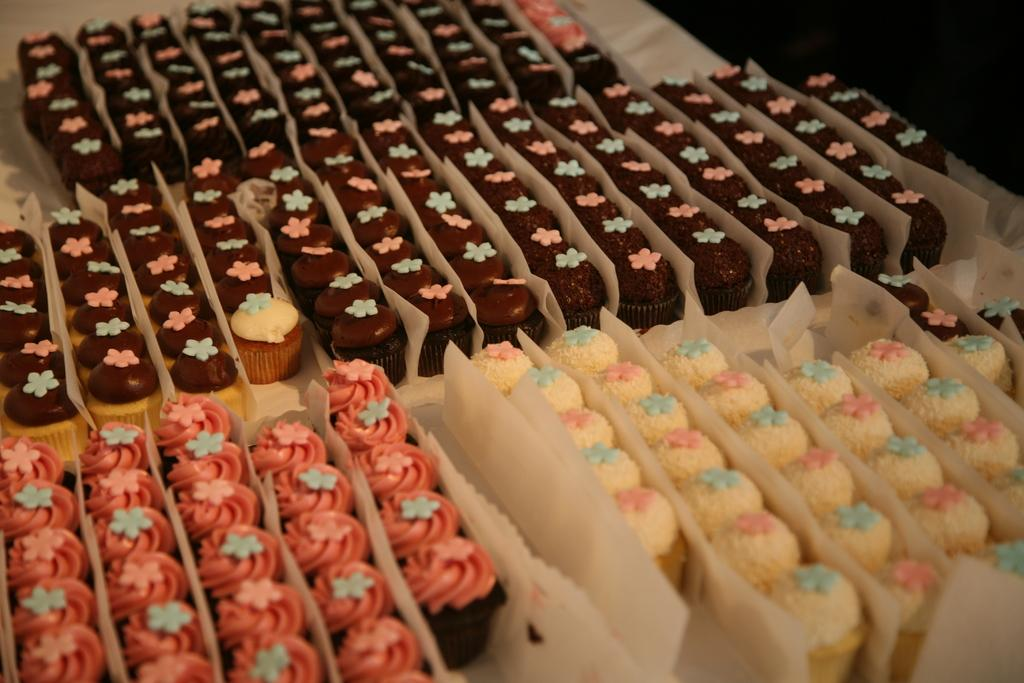What type of food is shown in the image? There are cupcakes in the image. How many different colors can be seen on the cupcakes? The cupcakes have four different colors: brown, white, peach, and blue. What is the color of the surface on which the cupcakes are placed? The cupcakes are on a white surface. What else is present in the image besides the cupcakes? There are butter papers in the image. What type of writing can be seen on the cupcakes in the image? There is no writing visible on the cupcakes in the image. 